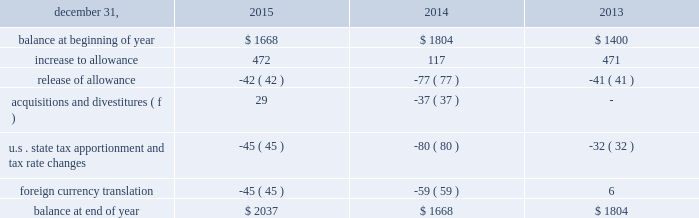The remaining $ 135 recognized in 2013 relates to a valuation allowance established on a portion of available foreign tax credits in the united states .
These credits can be carried forward for 10 years , and have an expiration period ranging from 2016 to 2023 as of december 31 , 2013 ( 2016 to 2025 as of december 31 , 2015 ) .
After weighing all available positive and negative evidence , as described above , management determined that it was no longer more likely than not that alcoa will realize the full tax benefit of these foreign tax credits .
This was primarily due to lower foreign sourced taxable income after consideration of tax planning strategies and after the inclusion of earnings from foreign subsidiaries projected to be distributable as taxable foreign dividends .
This valuation allowance was reevaluated as of december 31 , 2015 , and due to reductions in foreign sourced taxable income , a $ 134 discrete income tax charge was recognized .
Additionally , $ 15 of foreign tax credits expired at the end of 2015 resulting in a corresponding decrease to the valuation allowance .
At december 31 , 2015 , the amount of the valuation allowance was $ 254 .
The need for this valuation allowance will be assessed on a continuous basis in future periods and , as a result , an increase or decrease to this allowance may result based on changes in facts and circumstances .
In 2015 , alcoa recognized an additional $ 141 discrete income tax charge for valuation allowances on certain deferred tax assets in iceland and suriname .
Of this amount , an $ 85 valuation allowance was established on the full value of the deferred tax assets in suriname , which were related mostly to employee benefits and tax loss carryforwards .
These deferred tax assets have an expiration period ranging from 2016 to 2022 .
The remaining $ 56 charge relates to a valuation allowance established on a portion of the deferred tax assets recorded in iceland .
These deferred tax assets have an expiration period ranging from 2017 to 2023 .
After weighing all available positive and negative evidence , as described above , management determined that it was no longer more likely than not that alcoa will realize the tax benefit of either of these deferred tax assets .
This was mainly driven by a decline in the outlook of the primary metals business , combined with prior year cumulative losses and a short expiration period .
The need for this valuation allowance will be assessed on a continuous basis in future periods and , as a result , a portion or all of the allowance may be reversed based on changes in facts and circumstances .
In december 2011 , one of alcoa 2019s subsidiaries in brazil applied for a tax holiday related to its expanded mining and refining operations .
During 2013 , the application was amended and re-filed and , separately , a similar application was filed for another one of the company 2019s subsidiaries in brazil .
The deadline for the brazilian government to deny the application was july 11 , 2014 .
Since alcoa did not receive notice that its applications were denied , the tax holiday took effect automatically on july 12 , 2014 .
As a result , the tax rate applicable to qualified holiday income for these subsidiaries decreased significantly ( from 34% ( 34 % ) to 15.25% ( 15.25 % ) ) , resulting in future cash tax savings over the 10-year holiday period ( retroactively effective as of january 1 , 2013 ) .
Additionally , a portion of one of the subsidiaries net deferred tax asset that reverses within the holiday period was remeasured at the new tax rate ( the net deferred tax asset of the other subsidiary was not remeasured since it could still be utilized against the subsidiary 2019s future earnings not subject to the tax holiday ) .
This remeasurement resulted in a decrease to that subsidiary 2019s net deferred tax asset and a noncash charge to earnings of $ 52 ( $ 31 after noncontrolling interest ) .
The table details the changes in the valuation allowance: .
The cumulative amount of alcoa 2019s foreign undistributed net earnings for which no deferred taxes have been provided was approximately $ 4000 at december 31 , 2015 .
Alcoa has a number of commitments and obligations related to the company 2019s growth strategy in foreign jurisdictions .
As such , management has no plans to distribute such earnings in the foreseeable future , and , therefore , has determined it is not practicable to determine the related deferred tax liability. .
Considering the additional discrete income tax charge for valuation allowances in 2015 , what is the percentage of the valuation allowance of the deferred tax assets recorded in iceland? 
Rationale: it is iceland's valuation allowance of the deferred tax assets divided by the total additional discrete income tax charge for valuation allowances , then turned into a percentage .
Computations: (56 / 141)
Answer: 0.39716. The remaining $ 135 recognized in 2013 relates to a valuation allowance established on a portion of available foreign tax credits in the united states .
These credits can be carried forward for 10 years , and have an expiration period ranging from 2016 to 2023 as of december 31 , 2013 ( 2016 to 2025 as of december 31 , 2015 ) .
After weighing all available positive and negative evidence , as described above , management determined that it was no longer more likely than not that alcoa will realize the full tax benefit of these foreign tax credits .
This was primarily due to lower foreign sourced taxable income after consideration of tax planning strategies and after the inclusion of earnings from foreign subsidiaries projected to be distributable as taxable foreign dividends .
This valuation allowance was reevaluated as of december 31 , 2015 , and due to reductions in foreign sourced taxable income , a $ 134 discrete income tax charge was recognized .
Additionally , $ 15 of foreign tax credits expired at the end of 2015 resulting in a corresponding decrease to the valuation allowance .
At december 31 , 2015 , the amount of the valuation allowance was $ 254 .
The need for this valuation allowance will be assessed on a continuous basis in future periods and , as a result , an increase or decrease to this allowance may result based on changes in facts and circumstances .
In 2015 , alcoa recognized an additional $ 141 discrete income tax charge for valuation allowances on certain deferred tax assets in iceland and suriname .
Of this amount , an $ 85 valuation allowance was established on the full value of the deferred tax assets in suriname , which were related mostly to employee benefits and tax loss carryforwards .
These deferred tax assets have an expiration period ranging from 2016 to 2022 .
The remaining $ 56 charge relates to a valuation allowance established on a portion of the deferred tax assets recorded in iceland .
These deferred tax assets have an expiration period ranging from 2017 to 2023 .
After weighing all available positive and negative evidence , as described above , management determined that it was no longer more likely than not that alcoa will realize the tax benefit of either of these deferred tax assets .
This was mainly driven by a decline in the outlook of the primary metals business , combined with prior year cumulative losses and a short expiration period .
The need for this valuation allowance will be assessed on a continuous basis in future periods and , as a result , a portion or all of the allowance may be reversed based on changes in facts and circumstances .
In december 2011 , one of alcoa 2019s subsidiaries in brazil applied for a tax holiday related to its expanded mining and refining operations .
During 2013 , the application was amended and re-filed and , separately , a similar application was filed for another one of the company 2019s subsidiaries in brazil .
The deadline for the brazilian government to deny the application was july 11 , 2014 .
Since alcoa did not receive notice that its applications were denied , the tax holiday took effect automatically on july 12 , 2014 .
As a result , the tax rate applicable to qualified holiday income for these subsidiaries decreased significantly ( from 34% ( 34 % ) to 15.25% ( 15.25 % ) ) , resulting in future cash tax savings over the 10-year holiday period ( retroactively effective as of january 1 , 2013 ) .
Additionally , a portion of one of the subsidiaries net deferred tax asset that reverses within the holiday period was remeasured at the new tax rate ( the net deferred tax asset of the other subsidiary was not remeasured since it could still be utilized against the subsidiary 2019s future earnings not subject to the tax holiday ) .
This remeasurement resulted in a decrease to that subsidiary 2019s net deferred tax asset and a noncash charge to earnings of $ 52 ( $ 31 after noncontrolling interest ) .
The table details the changes in the valuation allowance: .
The cumulative amount of alcoa 2019s foreign undistributed net earnings for which no deferred taxes have been provided was approximately $ 4000 at december 31 , 2015 .
Alcoa has a number of commitments and obligations related to the company 2019s growth strategy in foreign jurisdictions .
As such , management has no plans to distribute such earnings in the foreseeable future , and , therefore , has determined it is not practicable to determine the related deferred tax liability. .
Taking the year 2015 , what is the increase to allowance as a percent of the balance at the end of the year? 
Rationale: it is the value of the increase to allowance divided by the total balance at the end of the year .
Computations: (472 / 2037)
Answer: 0.23171. 